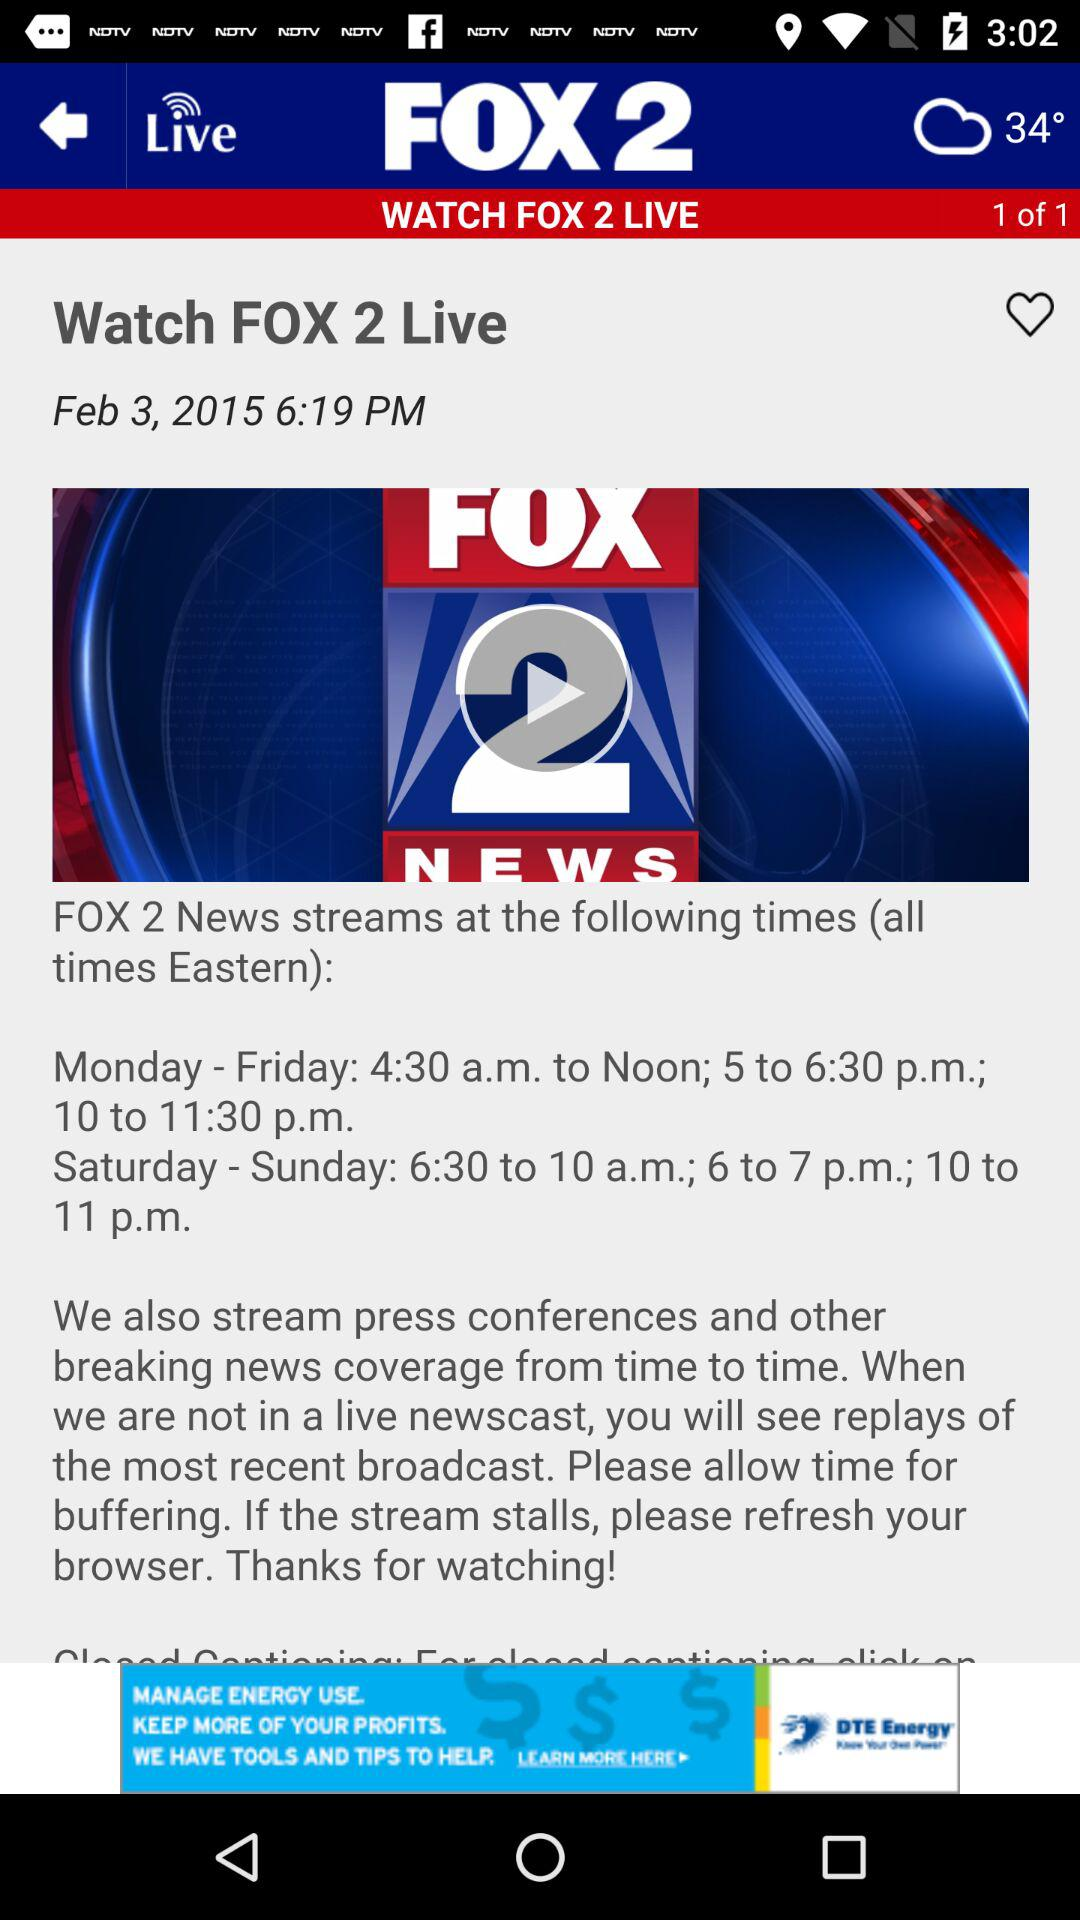What is the streaming time from Saturday to Sunday? The streaming times from Saturday to Sunday are 6:30 to 10 a.m., 6 to 7 p.m. and 10 to 11 p.m. 